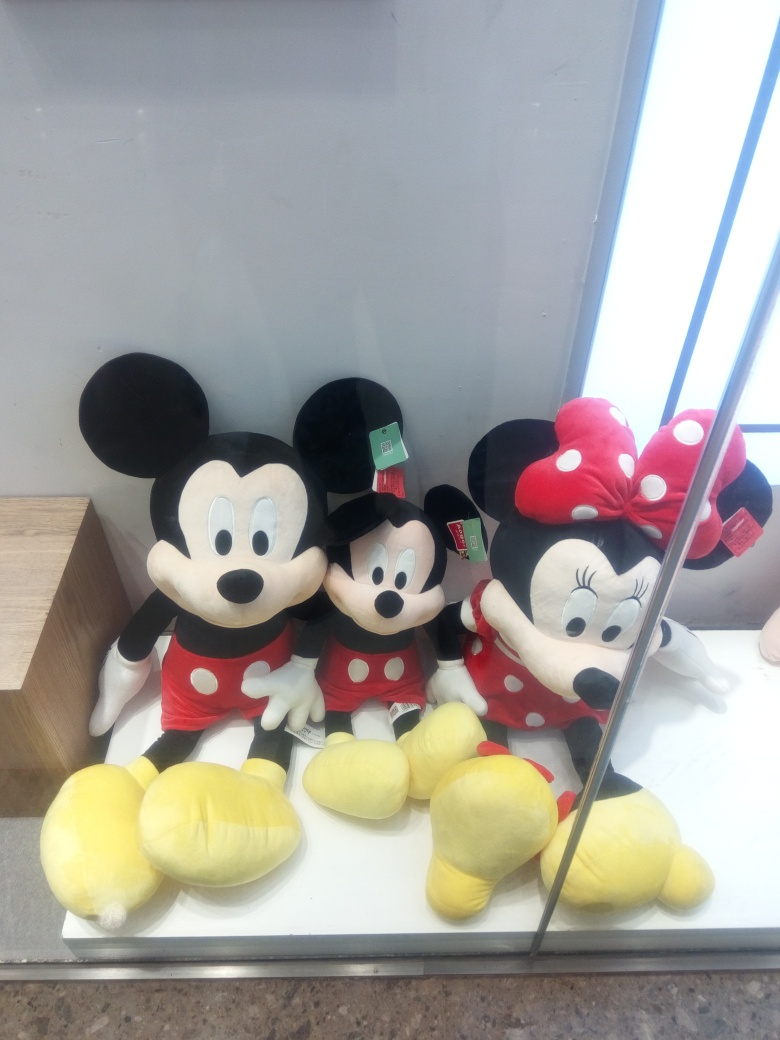Is the focus sharp in the photo? The focus in the photo is reasonably sharp, highlighting the details of the plush toys on display, which include two Mickey and one Minnie Mouse characters. The sharpness allows us to see the texture of the materials and the plush toys' expressions quite clearly. 